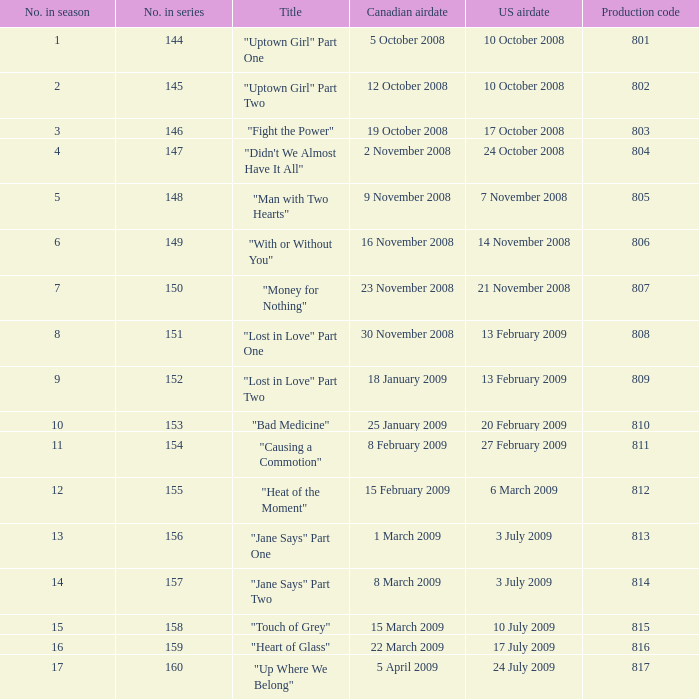How many U.S. air dates were from an episode in Season 4? 1.0. 